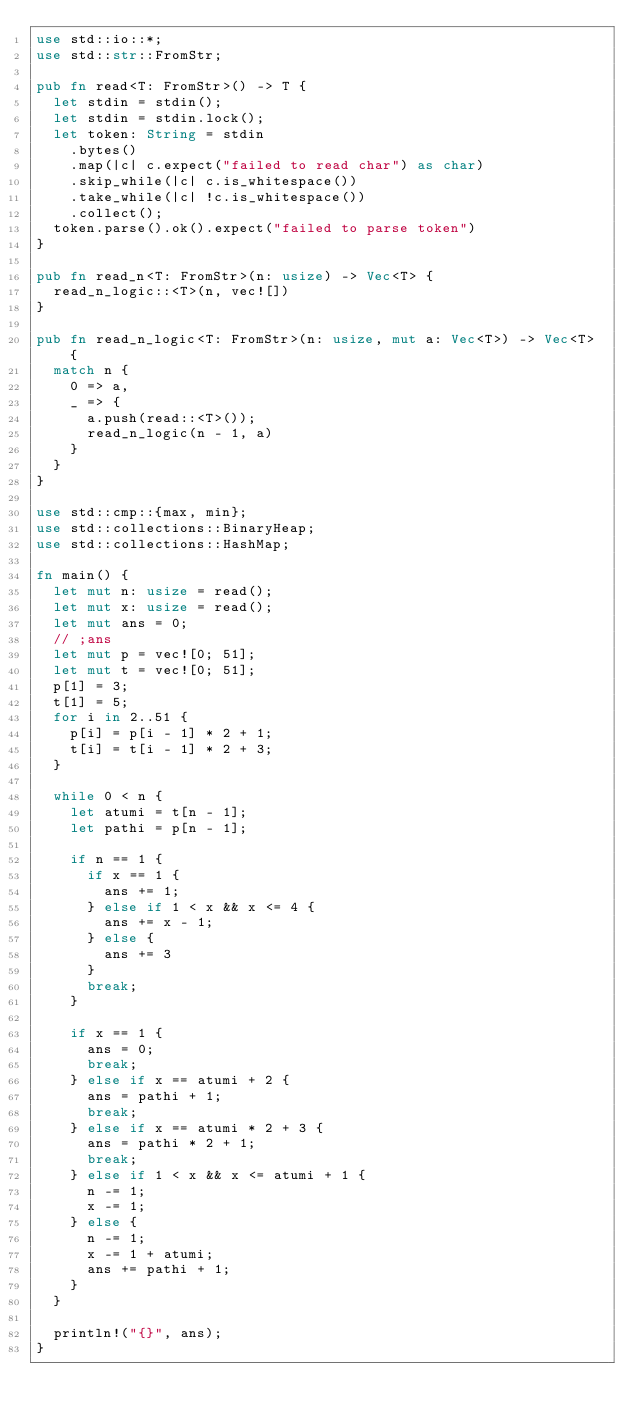Convert code to text. <code><loc_0><loc_0><loc_500><loc_500><_Rust_>use std::io::*;
use std::str::FromStr;

pub fn read<T: FromStr>() -> T {
  let stdin = stdin();
  let stdin = stdin.lock();
  let token: String = stdin
    .bytes()
    .map(|c| c.expect("failed to read char") as char)
    .skip_while(|c| c.is_whitespace())
    .take_while(|c| !c.is_whitespace())
    .collect();
  token.parse().ok().expect("failed to parse token")
}

pub fn read_n<T: FromStr>(n: usize) -> Vec<T> {
  read_n_logic::<T>(n, vec![])
}

pub fn read_n_logic<T: FromStr>(n: usize, mut a: Vec<T>) -> Vec<T> {
  match n {
    0 => a,
    _ => {
      a.push(read::<T>());
      read_n_logic(n - 1, a)
    }
  }
}

use std::cmp::{max, min};
use std::collections::BinaryHeap;
use std::collections::HashMap;

fn main() {
  let mut n: usize = read();
  let mut x: usize = read();
  let mut ans = 0;
  // ;ans
  let mut p = vec![0; 51];
  let mut t = vec![0; 51];
  p[1] = 3;
  t[1] = 5;
  for i in 2..51 {
    p[i] = p[i - 1] * 2 + 1;
    t[i] = t[i - 1] * 2 + 3;
  }

  while 0 < n {
    let atumi = t[n - 1];
    let pathi = p[n - 1];

    if n == 1 {
      if x == 1 {
        ans += 1;
      } else if 1 < x && x <= 4 {
        ans += x - 1;
      } else {
        ans += 3
      }
      break;
    }

    if x == 1 {
      ans = 0;
      break;
    } else if x == atumi + 2 {
      ans = pathi + 1;
      break;
    } else if x == atumi * 2 + 3 {
      ans = pathi * 2 + 1;
      break;
    } else if 1 < x && x <= atumi + 1 {
      n -= 1;
      x -= 1;
    } else {
      n -= 1;
      x -= 1 + atumi;
      ans += pathi + 1;
    }
  }

  println!("{}", ans);
}
</code> 